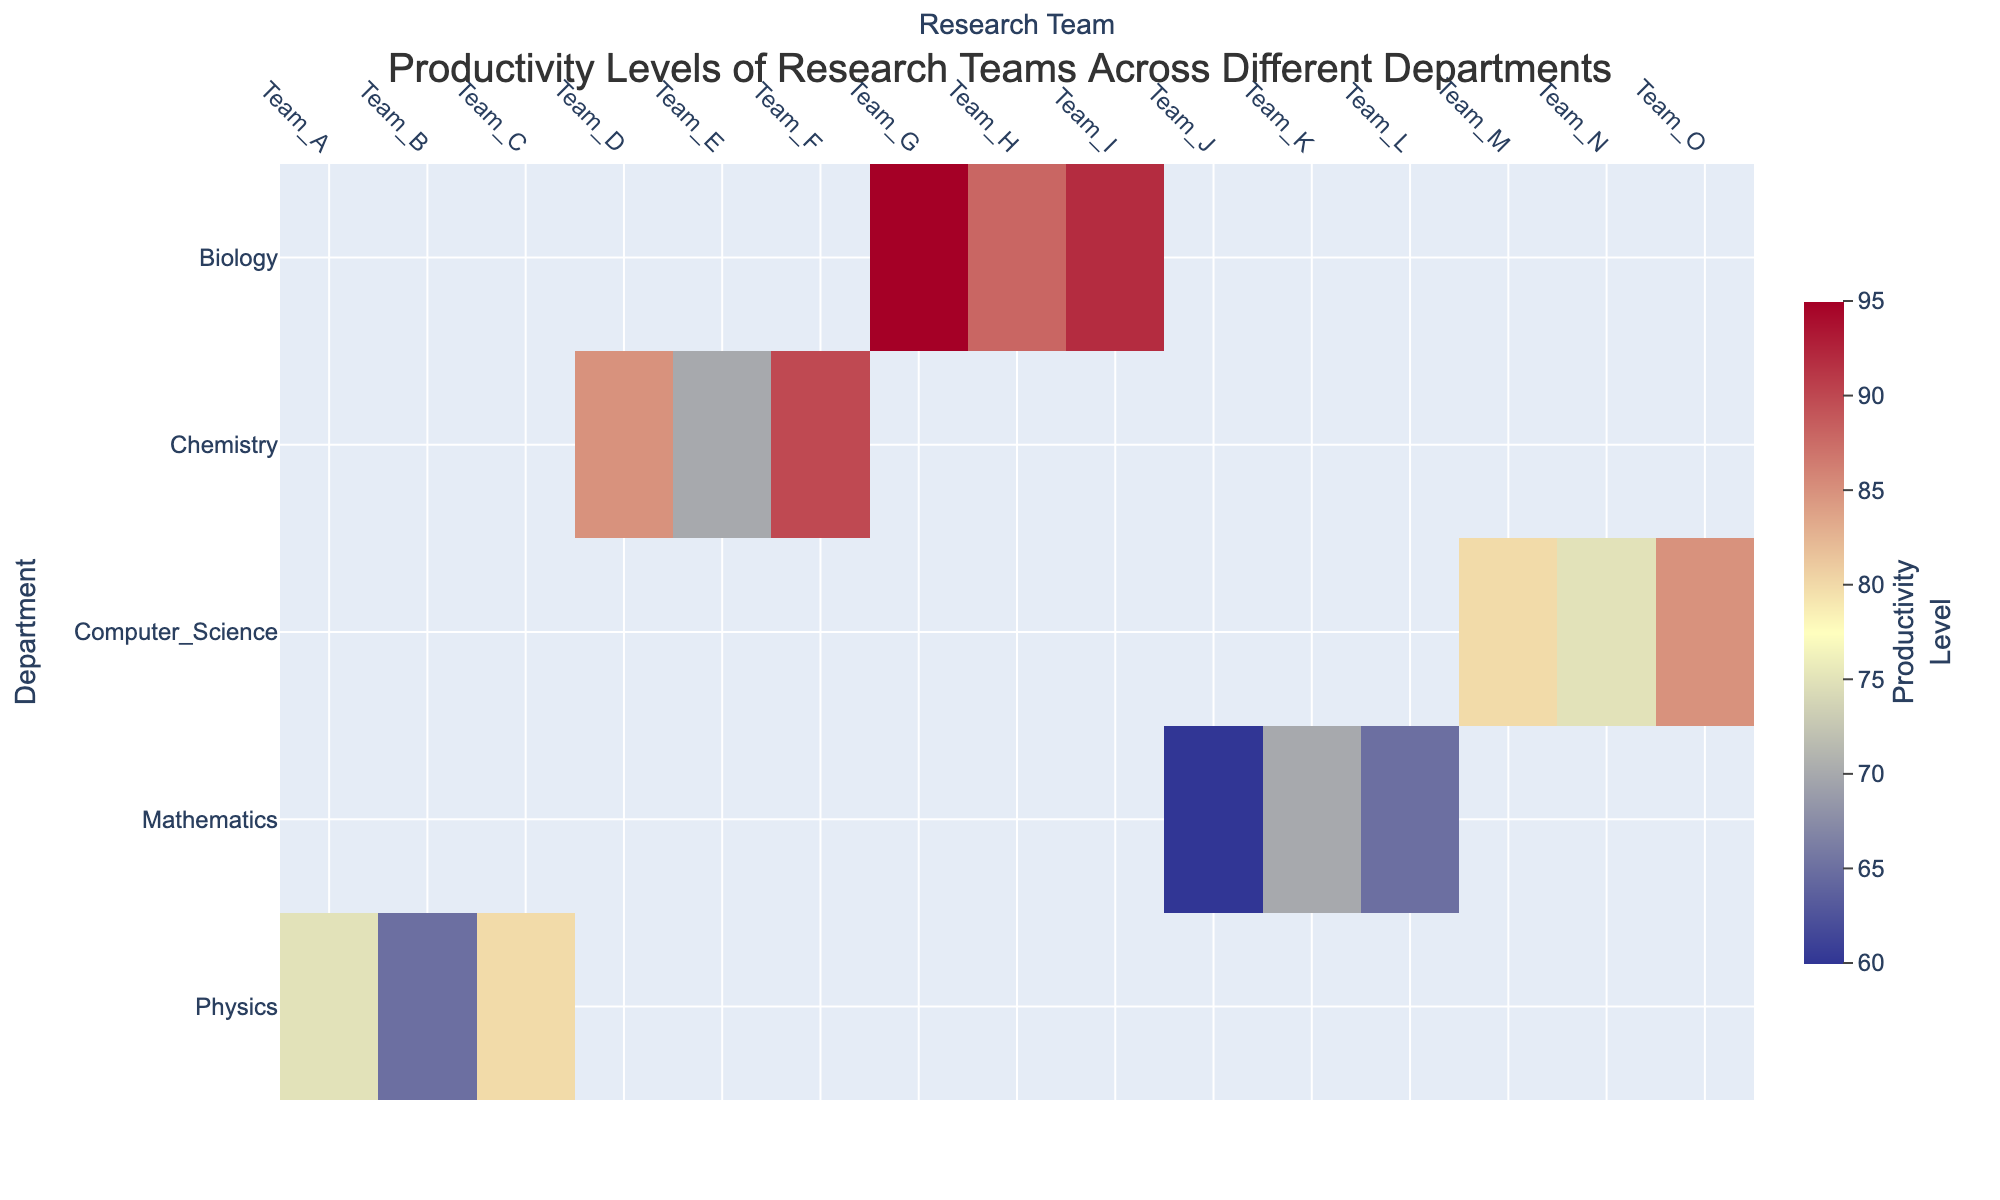What is the title of this heatmap? The title is typically located at the top of the figure. Here, the title "Productivity Levels of Research Teams Across Different Departments" indicates the main topic of the heatmap.
Answer: Productivity Levels of Research Teams Across Different Departments Which department has the research team with the highest productivity level? To find the department with the highest productivity level, look for the highest value on the heatmap. The highest value is 95, which corresponds to Biology, Team_G.
Answer: Biology How many research teams are represented in the Computer Science department? To find the number of research teams in a specific department, look at the columns corresponding to that department. For Computer Science, there are three teams: Team_M, Team_N, and Team_O.
Answer: 3 Which research team in the Physics department has the lowest productivity level? Compare the productivity levels of the teams within the Physics department. Team_B has the lowest productivity level at 65.
Answer: Team_B What is the difference in productivity levels between the highest and lowest teams in the Chemistry department? The highest productivity level in Chemistry is 90 (Team_F), and the lowest is 70 (Team_E). The difference is calculated as 90 - 70.
Answer: 20 What is the average productivity level of the research teams in the Biology department? Average the productivity levels of the Biology teams: (95 + 88 + 92) / 3 = 275 / 3 = 91.67.
Answer: 91.67 Which department has the most consistent productivity levels across its research teams? "Most consistent" can be determined by finding the department with the smallest range in productivity levels. Physics ranges from 65 to 80 (15), Chemistry from 70 to 90 (20), Biology from 88 to 95 (7), Mathematics from 60 to 70 (10), and Computer Science from 75 to 85 (10). Biology has the smallest range.
Answer: Biology How does the productivity level of Team_J compare to Team_L in the Mathematics department? Check the specific productivity levels of Team_J (60) and Team_L (65) and compare them. Team_L has a higher productivity level by 5 points.
Answer: Team_L What's the median productivity level of the research teams across all departments? Collect all productivity levels (75, 65, 80, 85, 70, 90, 95, 88, 92, 60, 70, 65, 80, 75, 85) and arrange them in ascending order: 60, 65, 65, 70, 70, 75, 75, 80, 80, 85, 85, 88, 90, 92, 95. The middle value in this ordered list is 80.
Answer: 80 